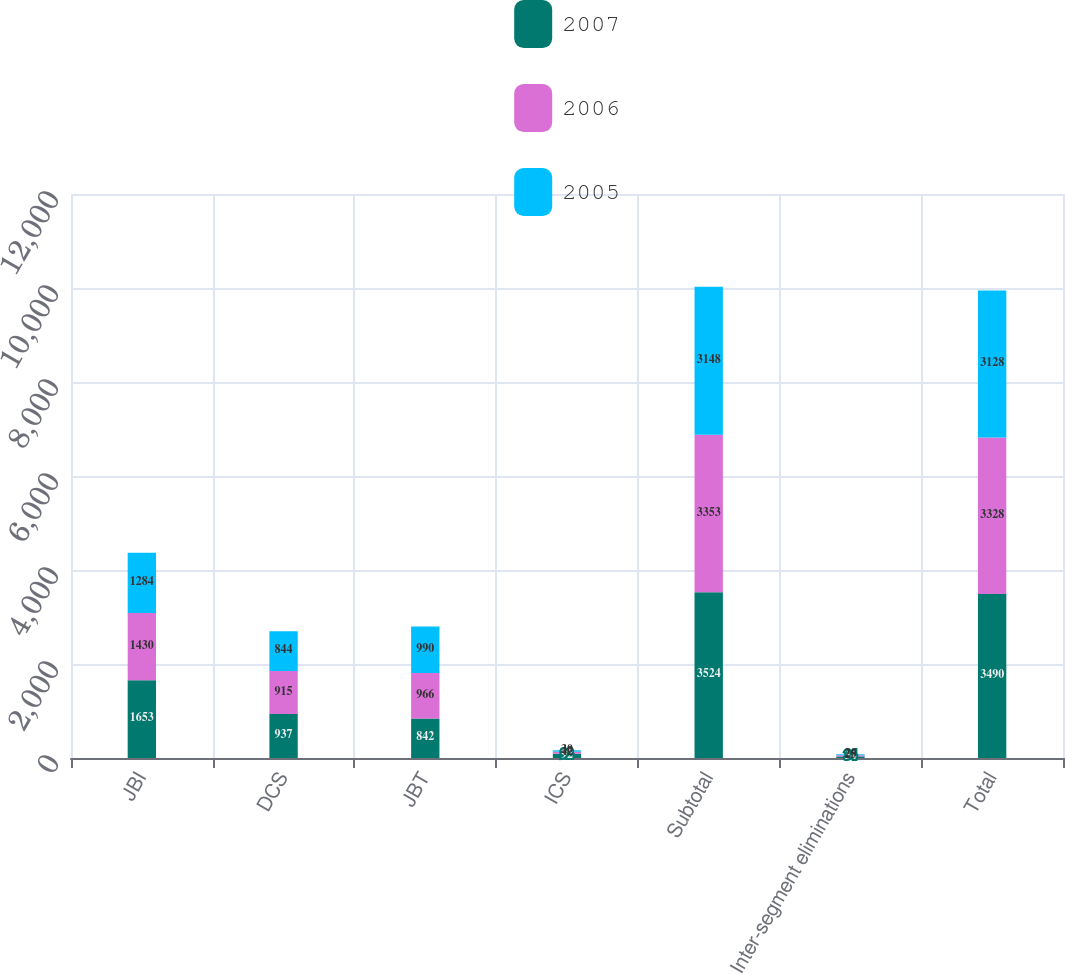<chart> <loc_0><loc_0><loc_500><loc_500><stacked_bar_chart><ecel><fcel>JBI<fcel>DCS<fcel>JBT<fcel>ICS<fcel>Subtotal<fcel>Inter-segment eliminations<fcel>Total<nl><fcel>2007<fcel>1653<fcel>937<fcel>842<fcel>92<fcel>3524<fcel>34<fcel>3490<nl><fcel>2006<fcel>1430<fcel>915<fcel>966<fcel>42<fcel>3353<fcel>25<fcel>3328<nl><fcel>2005<fcel>1284<fcel>844<fcel>990<fcel>30<fcel>3148<fcel>20<fcel>3128<nl></chart> 